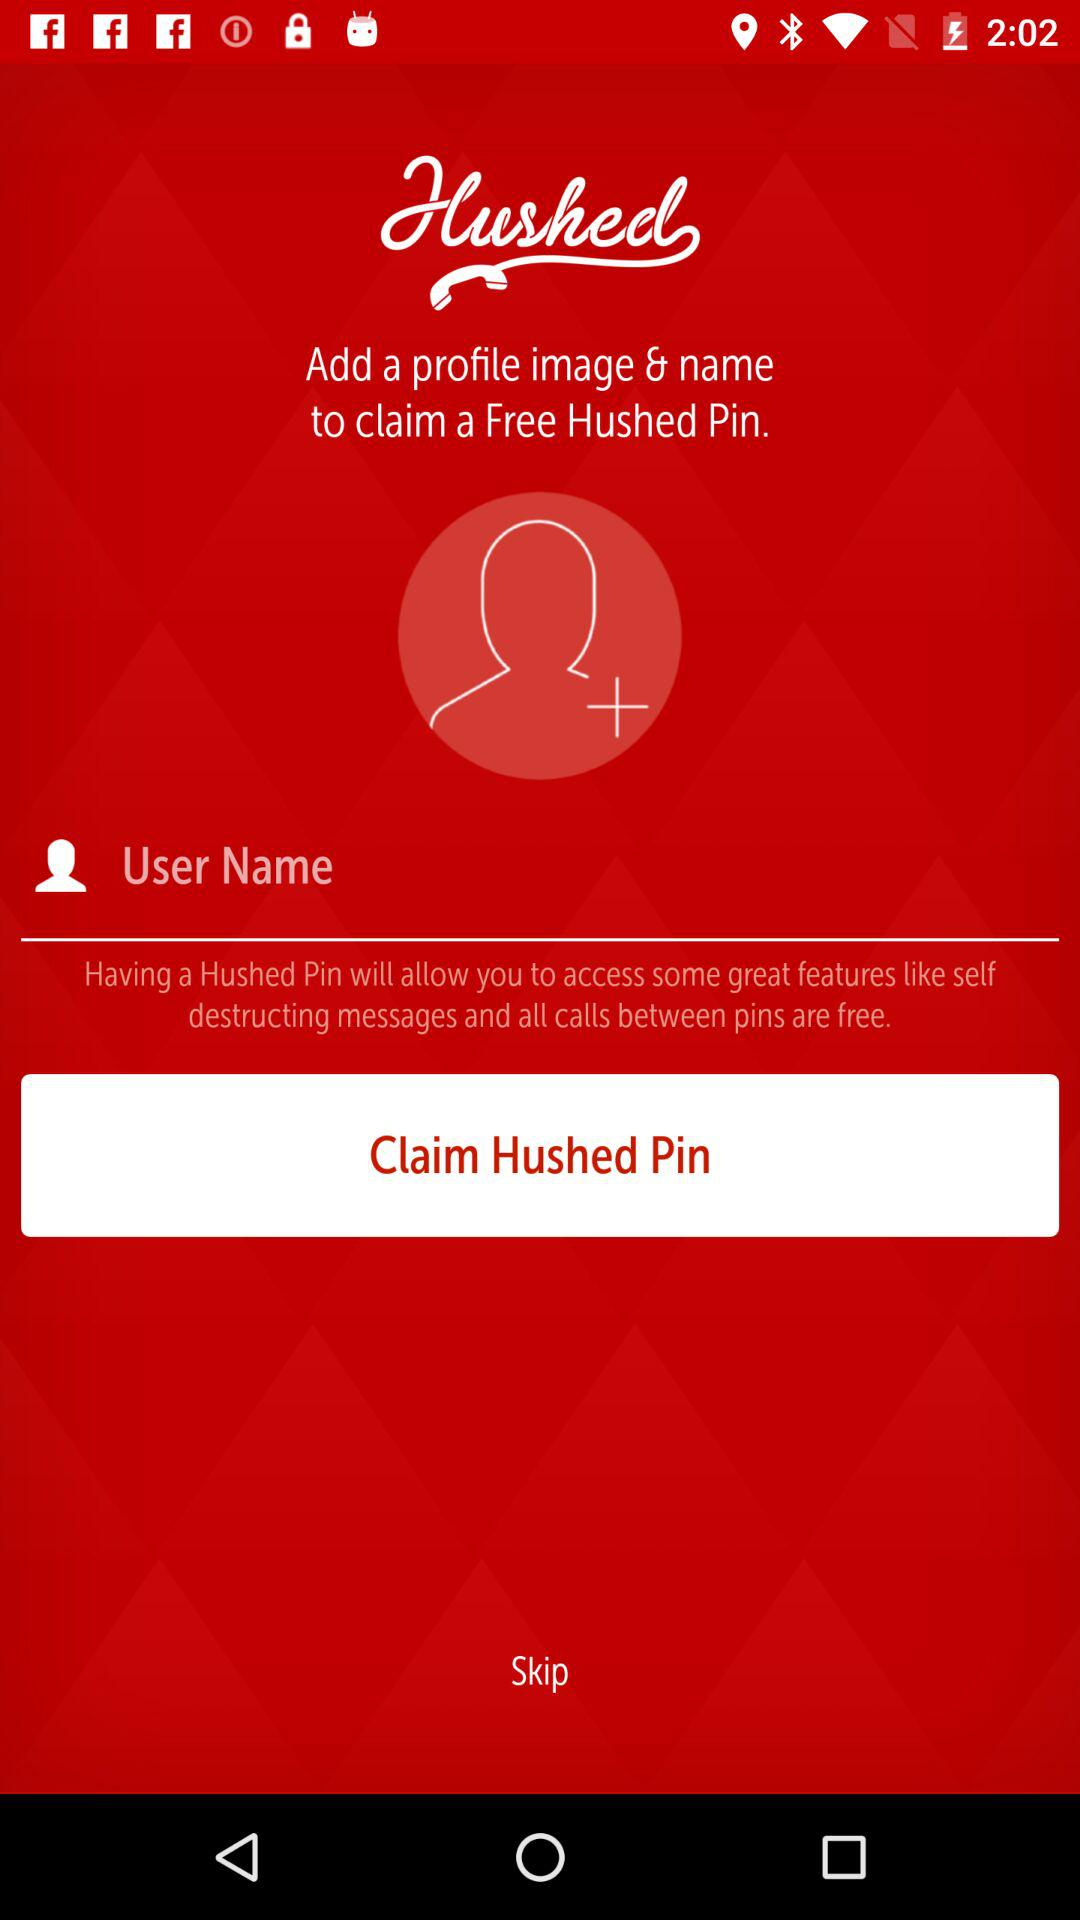What is to be claimed? The item to be claimed is a free Hushed Pin. 